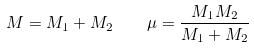Convert formula to latex. <formula><loc_0><loc_0><loc_500><loc_500>M = M _ { 1 } + M _ { 2 } \quad \mu = \frac { M _ { 1 } M _ { 2 } } { M _ { 1 } + M _ { 2 } }</formula> 